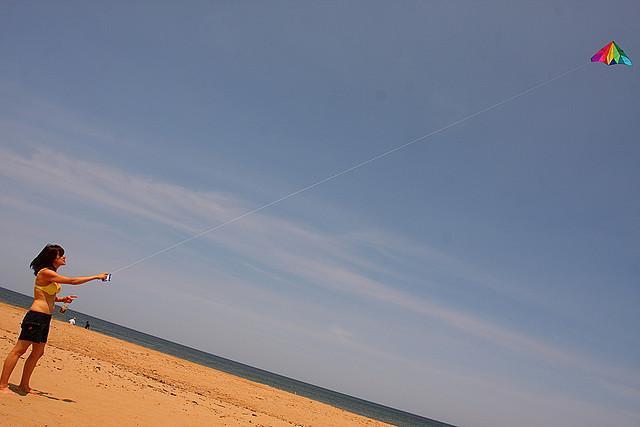How many people are in the photo?
Give a very brief answer. 1. 